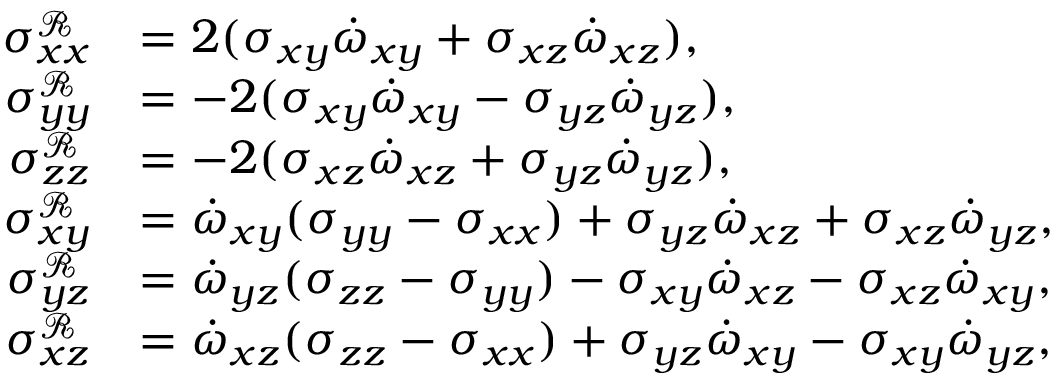Convert formula to latex. <formula><loc_0><loc_0><loc_500><loc_500>\begin{array} { r l } { \sigma _ { x x } ^ { \mathcal { R } } } & { = 2 ( \sigma _ { x y } \dot { \omega } _ { x y } + \sigma _ { x z } \dot { \omega } _ { x z } ) , } \\ { \sigma _ { y y } ^ { \mathcal { R } } } & { = - 2 ( \sigma _ { x y } \dot { \omega } _ { x y } - \sigma _ { y z } \dot { \omega } _ { y z } ) , } \\ { \sigma _ { z z } ^ { \mathcal { R } } } & { = - 2 ( \sigma _ { x z } \dot { \omega } _ { x z } + \sigma _ { y z } \dot { \omega } _ { y z } ) , } \\ { \sigma _ { x y } ^ { \mathcal { R } } } & { = \dot { \omega } _ { x y } ( \sigma _ { y y } - \sigma _ { x x } ) + \sigma _ { y z } \dot { \omega } _ { x z } + \sigma _ { x z } \dot { \omega } _ { y z } , } \\ { \sigma _ { y z } ^ { \mathcal { R } } } & { = \dot { \omega } _ { y z } ( \sigma _ { z z } - \sigma _ { y y } ) - \sigma _ { x y } \dot { \omega } _ { x z } - \sigma _ { x z } \dot { \omega } _ { x y } , } \\ { \sigma _ { x z } ^ { \mathcal { R } } } & { = \dot { \omega } _ { x z } ( \sigma _ { z z } - \sigma _ { x x } ) + \sigma _ { y z } \dot { \omega } _ { x y } - \sigma _ { x y } \dot { \omega } _ { y z } , } \end{array}</formula> 